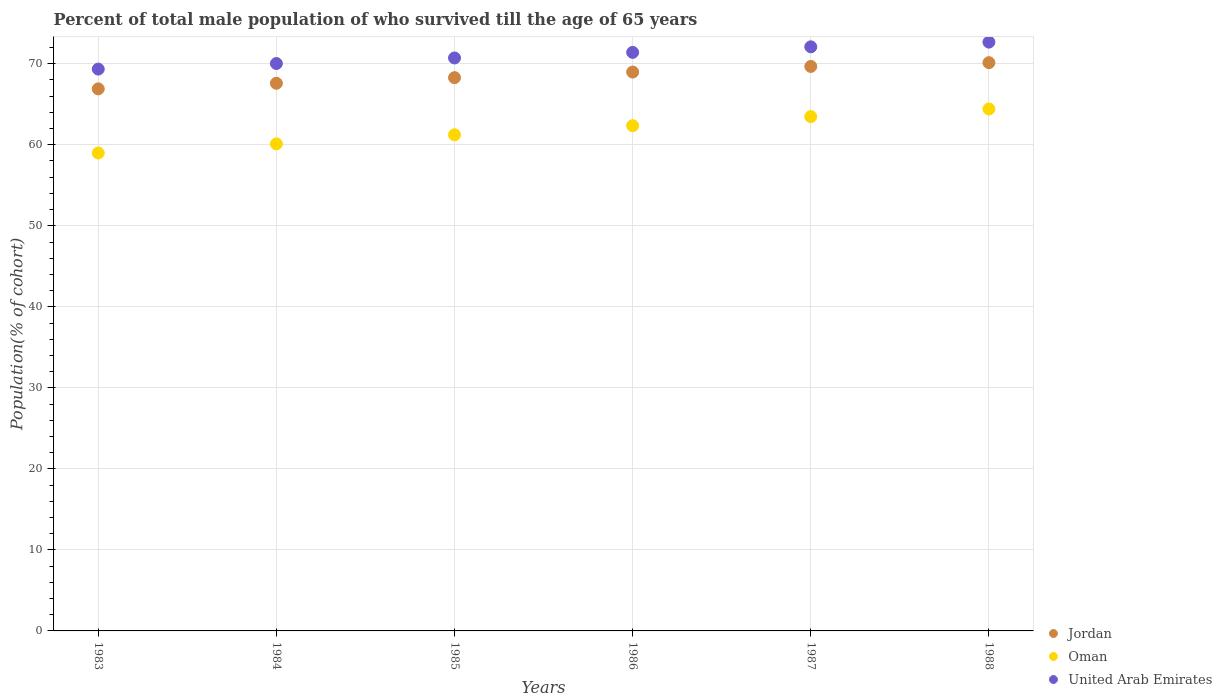How many different coloured dotlines are there?
Offer a terse response. 3. Is the number of dotlines equal to the number of legend labels?
Give a very brief answer. Yes. What is the percentage of total male population who survived till the age of 65 years in Jordan in 1985?
Offer a terse response. 68.29. Across all years, what is the maximum percentage of total male population who survived till the age of 65 years in United Arab Emirates?
Keep it short and to the point. 72.67. Across all years, what is the minimum percentage of total male population who survived till the age of 65 years in United Arab Emirates?
Provide a short and direct response. 69.34. In which year was the percentage of total male population who survived till the age of 65 years in United Arab Emirates minimum?
Your answer should be compact. 1983. What is the total percentage of total male population who survived till the age of 65 years in Oman in the graph?
Provide a succinct answer. 370.59. What is the difference between the percentage of total male population who survived till the age of 65 years in Oman in 1983 and that in 1986?
Offer a very short reply. -3.37. What is the difference between the percentage of total male population who survived till the age of 65 years in United Arab Emirates in 1985 and the percentage of total male population who survived till the age of 65 years in Oman in 1988?
Offer a very short reply. 6.3. What is the average percentage of total male population who survived till the age of 65 years in Jordan per year?
Offer a very short reply. 68.59. In the year 1987, what is the difference between the percentage of total male population who survived till the age of 65 years in Jordan and percentage of total male population who survived till the age of 65 years in Oman?
Offer a very short reply. 6.19. What is the ratio of the percentage of total male population who survived till the age of 65 years in United Arab Emirates in 1984 to that in 1987?
Ensure brevity in your answer.  0.97. Is the difference between the percentage of total male population who survived till the age of 65 years in Jordan in 1986 and 1987 greater than the difference between the percentage of total male population who survived till the age of 65 years in Oman in 1986 and 1987?
Keep it short and to the point. Yes. What is the difference between the highest and the second highest percentage of total male population who survived till the age of 65 years in Jordan?
Your response must be concise. 0.47. What is the difference between the highest and the lowest percentage of total male population who survived till the age of 65 years in United Arab Emirates?
Provide a succinct answer. 3.33. In how many years, is the percentage of total male population who survived till the age of 65 years in United Arab Emirates greater than the average percentage of total male population who survived till the age of 65 years in United Arab Emirates taken over all years?
Your answer should be compact. 3. Is the sum of the percentage of total male population who survived till the age of 65 years in United Arab Emirates in 1985 and 1988 greater than the maximum percentage of total male population who survived till the age of 65 years in Oman across all years?
Offer a terse response. Yes. Is it the case that in every year, the sum of the percentage of total male population who survived till the age of 65 years in Jordan and percentage of total male population who survived till the age of 65 years in Oman  is greater than the percentage of total male population who survived till the age of 65 years in United Arab Emirates?
Offer a terse response. Yes. Is the percentage of total male population who survived till the age of 65 years in Oman strictly greater than the percentage of total male population who survived till the age of 65 years in United Arab Emirates over the years?
Ensure brevity in your answer.  No. Does the graph contain grids?
Your response must be concise. Yes. How are the legend labels stacked?
Your answer should be very brief. Vertical. What is the title of the graph?
Your answer should be compact. Percent of total male population of who survived till the age of 65 years. What is the label or title of the X-axis?
Make the answer very short. Years. What is the label or title of the Y-axis?
Offer a terse response. Population(% of cohort). What is the Population(% of cohort) of Jordan in 1983?
Your answer should be compact. 66.9. What is the Population(% of cohort) in Oman in 1983?
Offer a very short reply. 58.99. What is the Population(% of cohort) in United Arab Emirates in 1983?
Offer a very short reply. 69.34. What is the Population(% of cohort) in Jordan in 1984?
Make the answer very short. 67.59. What is the Population(% of cohort) in Oman in 1984?
Give a very brief answer. 60.11. What is the Population(% of cohort) in United Arab Emirates in 1984?
Your answer should be very brief. 70.03. What is the Population(% of cohort) in Jordan in 1985?
Keep it short and to the point. 68.29. What is the Population(% of cohort) in Oman in 1985?
Your answer should be very brief. 61.23. What is the Population(% of cohort) of United Arab Emirates in 1985?
Ensure brevity in your answer.  70.72. What is the Population(% of cohort) in Jordan in 1986?
Your answer should be very brief. 68.98. What is the Population(% of cohort) in Oman in 1986?
Offer a very short reply. 62.36. What is the Population(% of cohort) of United Arab Emirates in 1986?
Provide a short and direct response. 71.41. What is the Population(% of cohort) in Jordan in 1987?
Your answer should be very brief. 69.67. What is the Population(% of cohort) in Oman in 1987?
Give a very brief answer. 63.48. What is the Population(% of cohort) of United Arab Emirates in 1987?
Your answer should be very brief. 72.09. What is the Population(% of cohort) in Jordan in 1988?
Offer a very short reply. 70.14. What is the Population(% of cohort) in Oman in 1988?
Ensure brevity in your answer.  64.42. What is the Population(% of cohort) of United Arab Emirates in 1988?
Provide a succinct answer. 72.67. Across all years, what is the maximum Population(% of cohort) in Jordan?
Provide a short and direct response. 70.14. Across all years, what is the maximum Population(% of cohort) in Oman?
Give a very brief answer. 64.42. Across all years, what is the maximum Population(% of cohort) of United Arab Emirates?
Offer a very short reply. 72.67. Across all years, what is the minimum Population(% of cohort) of Jordan?
Offer a very short reply. 66.9. Across all years, what is the minimum Population(% of cohort) of Oman?
Provide a succinct answer. 58.99. Across all years, what is the minimum Population(% of cohort) in United Arab Emirates?
Offer a very short reply. 69.34. What is the total Population(% of cohort) in Jordan in the graph?
Make the answer very short. 411.57. What is the total Population(% of cohort) of Oman in the graph?
Provide a succinct answer. 370.59. What is the total Population(% of cohort) of United Arab Emirates in the graph?
Keep it short and to the point. 426.26. What is the difference between the Population(% of cohort) in Jordan in 1983 and that in 1984?
Your answer should be compact. -0.69. What is the difference between the Population(% of cohort) of Oman in 1983 and that in 1984?
Your answer should be very brief. -1.12. What is the difference between the Population(% of cohort) of United Arab Emirates in 1983 and that in 1984?
Provide a succinct answer. -0.69. What is the difference between the Population(% of cohort) of Jordan in 1983 and that in 1985?
Your answer should be compact. -1.38. What is the difference between the Population(% of cohort) of Oman in 1983 and that in 1985?
Make the answer very short. -2.24. What is the difference between the Population(% of cohort) in United Arab Emirates in 1983 and that in 1985?
Your response must be concise. -1.37. What is the difference between the Population(% of cohort) of Jordan in 1983 and that in 1986?
Your response must be concise. -2.08. What is the difference between the Population(% of cohort) of Oman in 1983 and that in 1986?
Provide a succinct answer. -3.37. What is the difference between the Population(% of cohort) of United Arab Emirates in 1983 and that in 1986?
Ensure brevity in your answer.  -2.06. What is the difference between the Population(% of cohort) of Jordan in 1983 and that in 1987?
Give a very brief answer. -2.77. What is the difference between the Population(% of cohort) of Oman in 1983 and that in 1987?
Ensure brevity in your answer.  -4.49. What is the difference between the Population(% of cohort) of United Arab Emirates in 1983 and that in 1987?
Your answer should be compact. -2.75. What is the difference between the Population(% of cohort) of Jordan in 1983 and that in 1988?
Your answer should be very brief. -3.23. What is the difference between the Population(% of cohort) in Oman in 1983 and that in 1988?
Give a very brief answer. -5.43. What is the difference between the Population(% of cohort) in United Arab Emirates in 1983 and that in 1988?
Ensure brevity in your answer.  -3.33. What is the difference between the Population(% of cohort) in Jordan in 1984 and that in 1985?
Give a very brief answer. -0.69. What is the difference between the Population(% of cohort) of Oman in 1984 and that in 1985?
Give a very brief answer. -1.12. What is the difference between the Population(% of cohort) of United Arab Emirates in 1984 and that in 1985?
Your answer should be compact. -0.69. What is the difference between the Population(% of cohort) in Jordan in 1984 and that in 1986?
Offer a very short reply. -1.38. What is the difference between the Population(% of cohort) in Oman in 1984 and that in 1986?
Your response must be concise. -2.24. What is the difference between the Population(% of cohort) in United Arab Emirates in 1984 and that in 1986?
Your answer should be compact. -1.37. What is the difference between the Population(% of cohort) in Jordan in 1984 and that in 1987?
Give a very brief answer. -2.08. What is the difference between the Population(% of cohort) of Oman in 1984 and that in 1987?
Your answer should be compact. -3.37. What is the difference between the Population(% of cohort) of United Arab Emirates in 1984 and that in 1987?
Offer a terse response. -2.06. What is the difference between the Population(% of cohort) of Jordan in 1984 and that in 1988?
Offer a very short reply. -2.54. What is the difference between the Population(% of cohort) in Oman in 1984 and that in 1988?
Keep it short and to the point. -4.31. What is the difference between the Population(% of cohort) in United Arab Emirates in 1984 and that in 1988?
Your answer should be very brief. -2.64. What is the difference between the Population(% of cohort) of Jordan in 1985 and that in 1986?
Keep it short and to the point. -0.69. What is the difference between the Population(% of cohort) of Oman in 1985 and that in 1986?
Your response must be concise. -1.12. What is the difference between the Population(% of cohort) of United Arab Emirates in 1985 and that in 1986?
Provide a short and direct response. -0.69. What is the difference between the Population(% of cohort) of Jordan in 1985 and that in 1987?
Offer a very short reply. -1.38. What is the difference between the Population(% of cohort) of Oman in 1985 and that in 1987?
Ensure brevity in your answer.  -2.24. What is the difference between the Population(% of cohort) in United Arab Emirates in 1985 and that in 1987?
Your response must be concise. -1.37. What is the difference between the Population(% of cohort) of Jordan in 1985 and that in 1988?
Offer a terse response. -1.85. What is the difference between the Population(% of cohort) in Oman in 1985 and that in 1988?
Your answer should be very brief. -3.18. What is the difference between the Population(% of cohort) of United Arab Emirates in 1985 and that in 1988?
Provide a succinct answer. -1.95. What is the difference between the Population(% of cohort) of Jordan in 1986 and that in 1987?
Provide a succinct answer. -0.69. What is the difference between the Population(% of cohort) of Oman in 1986 and that in 1987?
Provide a short and direct response. -1.12. What is the difference between the Population(% of cohort) in United Arab Emirates in 1986 and that in 1987?
Offer a very short reply. -0.69. What is the difference between the Population(% of cohort) in Jordan in 1986 and that in 1988?
Your answer should be compact. -1.16. What is the difference between the Population(% of cohort) in Oman in 1986 and that in 1988?
Keep it short and to the point. -2.06. What is the difference between the Population(% of cohort) in United Arab Emirates in 1986 and that in 1988?
Provide a short and direct response. -1.27. What is the difference between the Population(% of cohort) in Jordan in 1987 and that in 1988?
Your response must be concise. -0.47. What is the difference between the Population(% of cohort) of Oman in 1987 and that in 1988?
Offer a terse response. -0.94. What is the difference between the Population(% of cohort) of United Arab Emirates in 1987 and that in 1988?
Offer a terse response. -0.58. What is the difference between the Population(% of cohort) of Jordan in 1983 and the Population(% of cohort) of Oman in 1984?
Your answer should be compact. 6.79. What is the difference between the Population(% of cohort) in Jordan in 1983 and the Population(% of cohort) in United Arab Emirates in 1984?
Make the answer very short. -3.13. What is the difference between the Population(% of cohort) in Oman in 1983 and the Population(% of cohort) in United Arab Emirates in 1984?
Provide a short and direct response. -11.04. What is the difference between the Population(% of cohort) of Jordan in 1983 and the Population(% of cohort) of Oman in 1985?
Offer a terse response. 5.67. What is the difference between the Population(% of cohort) in Jordan in 1983 and the Population(% of cohort) in United Arab Emirates in 1985?
Provide a short and direct response. -3.82. What is the difference between the Population(% of cohort) in Oman in 1983 and the Population(% of cohort) in United Arab Emirates in 1985?
Give a very brief answer. -11.73. What is the difference between the Population(% of cohort) in Jordan in 1983 and the Population(% of cohort) in Oman in 1986?
Your response must be concise. 4.55. What is the difference between the Population(% of cohort) of Jordan in 1983 and the Population(% of cohort) of United Arab Emirates in 1986?
Keep it short and to the point. -4.5. What is the difference between the Population(% of cohort) in Oman in 1983 and the Population(% of cohort) in United Arab Emirates in 1986?
Provide a succinct answer. -12.42. What is the difference between the Population(% of cohort) in Jordan in 1983 and the Population(% of cohort) in Oman in 1987?
Make the answer very short. 3.42. What is the difference between the Population(% of cohort) in Jordan in 1983 and the Population(% of cohort) in United Arab Emirates in 1987?
Your answer should be compact. -5.19. What is the difference between the Population(% of cohort) of Oman in 1983 and the Population(% of cohort) of United Arab Emirates in 1987?
Keep it short and to the point. -13.1. What is the difference between the Population(% of cohort) in Jordan in 1983 and the Population(% of cohort) in Oman in 1988?
Your answer should be very brief. 2.48. What is the difference between the Population(% of cohort) in Jordan in 1983 and the Population(% of cohort) in United Arab Emirates in 1988?
Your answer should be very brief. -5.77. What is the difference between the Population(% of cohort) of Oman in 1983 and the Population(% of cohort) of United Arab Emirates in 1988?
Provide a succinct answer. -13.68. What is the difference between the Population(% of cohort) in Jordan in 1984 and the Population(% of cohort) in Oman in 1985?
Ensure brevity in your answer.  6.36. What is the difference between the Population(% of cohort) in Jordan in 1984 and the Population(% of cohort) in United Arab Emirates in 1985?
Provide a succinct answer. -3.12. What is the difference between the Population(% of cohort) in Oman in 1984 and the Population(% of cohort) in United Arab Emirates in 1985?
Keep it short and to the point. -10.61. What is the difference between the Population(% of cohort) of Jordan in 1984 and the Population(% of cohort) of Oman in 1986?
Make the answer very short. 5.24. What is the difference between the Population(% of cohort) of Jordan in 1984 and the Population(% of cohort) of United Arab Emirates in 1986?
Give a very brief answer. -3.81. What is the difference between the Population(% of cohort) in Oman in 1984 and the Population(% of cohort) in United Arab Emirates in 1986?
Make the answer very short. -11.29. What is the difference between the Population(% of cohort) of Jordan in 1984 and the Population(% of cohort) of Oman in 1987?
Your answer should be very brief. 4.12. What is the difference between the Population(% of cohort) of Jordan in 1984 and the Population(% of cohort) of United Arab Emirates in 1987?
Make the answer very short. -4.5. What is the difference between the Population(% of cohort) of Oman in 1984 and the Population(% of cohort) of United Arab Emirates in 1987?
Keep it short and to the point. -11.98. What is the difference between the Population(% of cohort) in Jordan in 1984 and the Population(% of cohort) in Oman in 1988?
Give a very brief answer. 3.18. What is the difference between the Population(% of cohort) of Jordan in 1984 and the Population(% of cohort) of United Arab Emirates in 1988?
Provide a succinct answer. -5.08. What is the difference between the Population(% of cohort) of Oman in 1984 and the Population(% of cohort) of United Arab Emirates in 1988?
Your answer should be very brief. -12.56. What is the difference between the Population(% of cohort) of Jordan in 1985 and the Population(% of cohort) of Oman in 1986?
Give a very brief answer. 5.93. What is the difference between the Population(% of cohort) of Jordan in 1985 and the Population(% of cohort) of United Arab Emirates in 1986?
Make the answer very short. -3.12. What is the difference between the Population(% of cohort) in Oman in 1985 and the Population(% of cohort) in United Arab Emirates in 1986?
Your answer should be compact. -10.17. What is the difference between the Population(% of cohort) of Jordan in 1985 and the Population(% of cohort) of Oman in 1987?
Provide a short and direct response. 4.81. What is the difference between the Population(% of cohort) of Jordan in 1985 and the Population(% of cohort) of United Arab Emirates in 1987?
Provide a succinct answer. -3.81. What is the difference between the Population(% of cohort) of Oman in 1985 and the Population(% of cohort) of United Arab Emirates in 1987?
Offer a terse response. -10.86. What is the difference between the Population(% of cohort) of Jordan in 1985 and the Population(% of cohort) of Oman in 1988?
Your response must be concise. 3.87. What is the difference between the Population(% of cohort) in Jordan in 1985 and the Population(% of cohort) in United Arab Emirates in 1988?
Your response must be concise. -4.39. What is the difference between the Population(% of cohort) in Oman in 1985 and the Population(% of cohort) in United Arab Emirates in 1988?
Offer a very short reply. -11.44. What is the difference between the Population(% of cohort) in Jordan in 1986 and the Population(% of cohort) in Oman in 1987?
Keep it short and to the point. 5.5. What is the difference between the Population(% of cohort) of Jordan in 1986 and the Population(% of cohort) of United Arab Emirates in 1987?
Your response must be concise. -3.11. What is the difference between the Population(% of cohort) of Oman in 1986 and the Population(% of cohort) of United Arab Emirates in 1987?
Your answer should be compact. -9.74. What is the difference between the Population(% of cohort) in Jordan in 1986 and the Population(% of cohort) in Oman in 1988?
Give a very brief answer. 4.56. What is the difference between the Population(% of cohort) of Jordan in 1986 and the Population(% of cohort) of United Arab Emirates in 1988?
Your response must be concise. -3.69. What is the difference between the Population(% of cohort) in Oman in 1986 and the Population(% of cohort) in United Arab Emirates in 1988?
Offer a terse response. -10.32. What is the difference between the Population(% of cohort) of Jordan in 1987 and the Population(% of cohort) of Oman in 1988?
Offer a terse response. 5.25. What is the difference between the Population(% of cohort) of Jordan in 1987 and the Population(% of cohort) of United Arab Emirates in 1988?
Your response must be concise. -3. What is the difference between the Population(% of cohort) of Oman in 1987 and the Population(% of cohort) of United Arab Emirates in 1988?
Provide a succinct answer. -9.19. What is the average Population(% of cohort) in Jordan per year?
Give a very brief answer. 68.59. What is the average Population(% of cohort) in Oman per year?
Your answer should be compact. 61.76. What is the average Population(% of cohort) of United Arab Emirates per year?
Make the answer very short. 71.04. In the year 1983, what is the difference between the Population(% of cohort) in Jordan and Population(% of cohort) in Oman?
Your response must be concise. 7.91. In the year 1983, what is the difference between the Population(% of cohort) of Jordan and Population(% of cohort) of United Arab Emirates?
Your answer should be compact. -2.44. In the year 1983, what is the difference between the Population(% of cohort) in Oman and Population(% of cohort) in United Arab Emirates?
Your response must be concise. -10.35. In the year 1984, what is the difference between the Population(% of cohort) in Jordan and Population(% of cohort) in Oman?
Your response must be concise. 7.48. In the year 1984, what is the difference between the Population(% of cohort) in Jordan and Population(% of cohort) in United Arab Emirates?
Make the answer very short. -2.44. In the year 1984, what is the difference between the Population(% of cohort) in Oman and Population(% of cohort) in United Arab Emirates?
Provide a succinct answer. -9.92. In the year 1985, what is the difference between the Population(% of cohort) in Jordan and Population(% of cohort) in Oman?
Ensure brevity in your answer.  7.05. In the year 1985, what is the difference between the Population(% of cohort) of Jordan and Population(% of cohort) of United Arab Emirates?
Keep it short and to the point. -2.43. In the year 1985, what is the difference between the Population(% of cohort) of Oman and Population(% of cohort) of United Arab Emirates?
Your answer should be compact. -9.48. In the year 1986, what is the difference between the Population(% of cohort) in Jordan and Population(% of cohort) in Oman?
Your response must be concise. 6.62. In the year 1986, what is the difference between the Population(% of cohort) in Jordan and Population(% of cohort) in United Arab Emirates?
Keep it short and to the point. -2.43. In the year 1986, what is the difference between the Population(% of cohort) in Oman and Population(% of cohort) in United Arab Emirates?
Offer a terse response. -9.05. In the year 1987, what is the difference between the Population(% of cohort) of Jordan and Population(% of cohort) of Oman?
Give a very brief answer. 6.19. In the year 1987, what is the difference between the Population(% of cohort) in Jordan and Population(% of cohort) in United Arab Emirates?
Ensure brevity in your answer.  -2.42. In the year 1987, what is the difference between the Population(% of cohort) in Oman and Population(% of cohort) in United Arab Emirates?
Ensure brevity in your answer.  -8.61. In the year 1988, what is the difference between the Population(% of cohort) in Jordan and Population(% of cohort) in Oman?
Ensure brevity in your answer.  5.72. In the year 1988, what is the difference between the Population(% of cohort) in Jordan and Population(% of cohort) in United Arab Emirates?
Your answer should be very brief. -2.53. In the year 1988, what is the difference between the Population(% of cohort) of Oman and Population(% of cohort) of United Arab Emirates?
Ensure brevity in your answer.  -8.25. What is the ratio of the Population(% of cohort) of Jordan in 1983 to that in 1984?
Give a very brief answer. 0.99. What is the ratio of the Population(% of cohort) in Oman in 1983 to that in 1984?
Provide a short and direct response. 0.98. What is the ratio of the Population(% of cohort) in United Arab Emirates in 1983 to that in 1984?
Your response must be concise. 0.99. What is the ratio of the Population(% of cohort) in Jordan in 1983 to that in 1985?
Provide a short and direct response. 0.98. What is the ratio of the Population(% of cohort) in Oman in 1983 to that in 1985?
Give a very brief answer. 0.96. What is the ratio of the Population(% of cohort) of United Arab Emirates in 1983 to that in 1985?
Your response must be concise. 0.98. What is the ratio of the Population(% of cohort) of Jordan in 1983 to that in 1986?
Give a very brief answer. 0.97. What is the ratio of the Population(% of cohort) in Oman in 1983 to that in 1986?
Your answer should be very brief. 0.95. What is the ratio of the Population(% of cohort) in United Arab Emirates in 1983 to that in 1986?
Ensure brevity in your answer.  0.97. What is the ratio of the Population(% of cohort) of Jordan in 1983 to that in 1987?
Your response must be concise. 0.96. What is the ratio of the Population(% of cohort) in Oman in 1983 to that in 1987?
Your response must be concise. 0.93. What is the ratio of the Population(% of cohort) in United Arab Emirates in 1983 to that in 1987?
Your answer should be very brief. 0.96. What is the ratio of the Population(% of cohort) of Jordan in 1983 to that in 1988?
Give a very brief answer. 0.95. What is the ratio of the Population(% of cohort) in Oman in 1983 to that in 1988?
Offer a very short reply. 0.92. What is the ratio of the Population(% of cohort) in United Arab Emirates in 1983 to that in 1988?
Make the answer very short. 0.95. What is the ratio of the Population(% of cohort) of Jordan in 1984 to that in 1985?
Ensure brevity in your answer.  0.99. What is the ratio of the Population(% of cohort) in Oman in 1984 to that in 1985?
Give a very brief answer. 0.98. What is the ratio of the Population(% of cohort) of United Arab Emirates in 1984 to that in 1985?
Make the answer very short. 0.99. What is the ratio of the Population(% of cohort) of Jordan in 1984 to that in 1986?
Your response must be concise. 0.98. What is the ratio of the Population(% of cohort) in United Arab Emirates in 1984 to that in 1986?
Keep it short and to the point. 0.98. What is the ratio of the Population(% of cohort) of Jordan in 1984 to that in 1987?
Keep it short and to the point. 0.97. What is the ratio of the Population(% of cohort) in Oman in 1984 to that in 1987?
Make the answer very short. 0.95. What is the ratio of the Population(% of cohort) in United Arab Emirates in 1984 to that in 1987?
Give a very brief answer. 0.97. What is the ratio of the Population(% of cohort) of Jordan in 1984 to that in 1988?
Ensure brevity in your answer.  0.96. What is the ratio of the Population(% of cohort) in Oman in 1984 to that in 1988?
Keep it short and to the point. 0.93. What is the ratio of the Population(% of cohort) in United Arab Emirates in 1984 to that in 1988?
Your response must be concise. 0.96. What is the ratio of the Population(% of cohort) of Oman in 1985 to that in 1986?
Provide a short and direct response. 0.98. What is the ratio of the Population(% of cohort) in Jordan in 1985 to that in 1987?
Make the answer very short. 0.98. What is the ratio of the Population(% of cohort) in Oman in 1985 to that in 1987?
Give a very brief answer. 0.96. What is the ratio of the Population(% of cohort) of United Arab Emirates in 1985 to that in 1987?
Provide a short and direct response. 0.98. What is the ratio of the Population(% of cohort) in Jordan in 1985 to that in 1988?
Make the answer very short. 0.97. What is the ratio of the Population(% of cohort) of Oman in 1985 to that in 1988?
Make the answer very short. 0.95. What is the ratio of the Population(% of cohort) of United Arab Emirates in 1985 to that in 1988?
Offer a very short reply. 0.97. What is the ratio of the Population(% of cohort) in Jordan in 1986 to that in 1987?
Offer a very short reply. 0.99. What is the ratio of the Population(% of cohort) in Oman in 1986 to that in 1987?
Offer a terse response. 0.98. What is the ratio of the Population(% of cohort) of United Arab Emirates in 1986 to that in 1987?
Make the answer very short. 0.99. What is the ratio of the Population(% of cohort) in Jordan in 1986 to that in 1988?
Offer a terse response. 0.98. What is the ratio of the Population(% of cohort) of Oman in 1986 to that in 1988?
Provide a short and direct response. 0.97. What is the ratio of the Population(% of cohort) of United Arab Emirates in 1986 to that in 1988?
Give a very brief answer. 0.98. What is the ratio of the Population(% of cohort) in Jordan in 1987 to that in 1988?
Give a very brief answer. 0.99. What is the ratio of the Population(% of cohort) in Oman in 1987 to that in 1988?
Your answer should be compact. 0.99. What is the difference between the highest and the second highest Population(% of cohort) of Jordan?
Your answer should be very brief. 0.47. What is the difference between the highest and the second highest Population(% of cohort) of Oman?
Provide a short and direct response. 0.94. What is the difference between the highest and the second highest Population(% of cohort) in United Arab Emirates?
Provide a short and direct response. 0.58. What is the difference between the highest and the lowest Population(% of cohort) in Jordan?
Your response must be concise. 3.23. What is the difference between the highest and the lowest Population(% of cohort) of Oman?
Your response must be concise. 5.43. What is the difference between the highest and the lowest Population(% of cohort) of United Arab Emirates?
Provide a short and direct response. 3.33. 